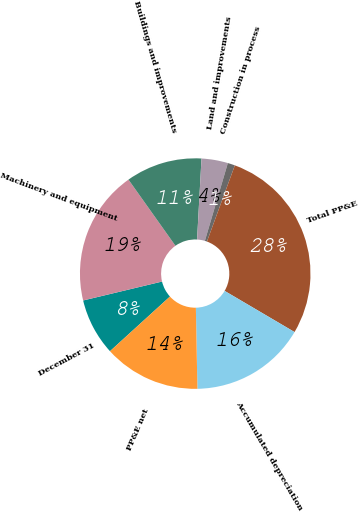Convert chart. <chart><loc_0><loc_0><loc_500><loc_500><pie_chart><fcel>December 31<fcel>Machinery and equipment<fcel>Buildings and improvements<fcel>Land and improvements<fcel>Construction in process<fcel>Total PP&E<fcel>Accumulated depreciation<fcel>PP&E net<nl><fcel>8.01%<fcel>18.92%<fcel>10.7%<fcel>3.7%<fcel>1.02%<fcel>27.88%<fcel>16.23%<fcel>13.55%<nl></chart> 